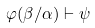<formula> <loc_0><loc_0><loc_500><loc_500>\varphi ( \beta / \alpha ) \vdash \psi</formula> 